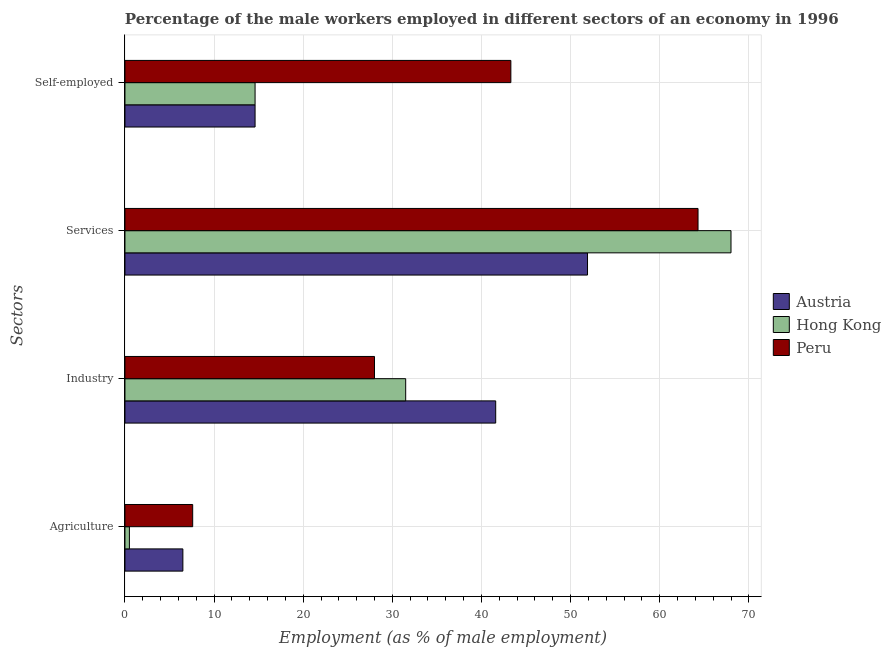How many different coloured bars are there?
Offer a very short reply. 3. How many groups of bars are there?
Ensure brevity in your answer.  4. Are the number of bars per tick equal to the number of legend labels?
Offer a terse response. Yes. Are the number of bars on each tick of the Y-axis equal?
Your answer should be compact. Yes. What is the label of the 3rd group of bars from the top?
Your answer should be compact. Industry. What is the percentage of male workers in services in Austria?
Provide a short and direct response. 51.9. Across all countries, what is the maximum percentage of male workers in agriculture?
Provide a short and direct response. 7.6. Across all countries, what is the minimum percentage of male workers in industry?
Make the answer very short. 28. In which country was the percentage of self employed male workers maximum?
Keep it short and to the point. Peru. What is the total percentage of self employed male workers in the graph?
Your answer should be very brief. 72.5. What is the difference between the percentage of self employed male workers in Austria and the percentage of male workers in services in Hong Kong?
Offer a terse response. -53.4. What is the average percentage of self employed male workers per country?
Offer a terse response. 24.17. What is the difference between the percentage of self employed male workers and percentage of male workers in services in Hong Kong?
Provide a short and direct response. -53.4. In how many countries, is the percentage of self employed male workers greater than 56 %?
Your response must be concise. 0. What is the ratio of the percentage of male workers in industry in Peru to that in Hong Kong?
Ensure brevity in your answer.  0.89. What is the difference between the highest and the second highest percentage of male workers in services?
Ensure brevity in your answer.  3.7. What is the difference between the highest and the lowest percentage of male workers in agriculture?
Offer a very short reply. 7.1. Is the sum of the percentage of male workers in industry in Peru and Austria greater than the maximum percentage of male workers in services across all countries?
Offer a very short reply. Yes. What does the 2nd bar from the bottom in Self-employed represents?
Your answer should be compact. Hong Kong. How many countries are there in the graph?
Provide a short and direct response. 3. What is the difference between two consecutive major ticks on the X-axis?
Offer a terse response. 10. Does the graph contain any zero values?
Provide a short and direct response. No. Where does the legend appear in the graph?
Make the answer very short. Center right. How many legend labels are there?
Provide a succinct answer. 3. What is the title of the graph?
Your response must be concise. Percentage of the male workers employed in different sectors of an economy in 1996. Does "Israel" appear as one of the legend labels in the graph?
Make the answer very short. No. What is the label or title of the X-axis?
Keep it short and to the point. Employment (as % of male employment). What is the label or title of the Y-axis?
Your response must be concise. Sectors. What is the Employment (as % of male employment) in Peru in Agriculture?
Your response must be concise. 7.6. What is the Employment (as % of male employment) in Austria in Industry?
Keep it short and to the point. 41.6. What is the Employment (as % of male employment) of Hong Kong in Industry?
Offer a terse response. 31.5. What is the Employment (as % of male employment) of Peru in Industry?
Your answer should be compact. 28. What is the Employment (as % of male employment) of Austria in Services?
Give a very brief answer. 51.9. What is the Employment (as % of male employment) of Hong Kong in Services?
Your response must be concise. 68. What is the Employment (as % of male employment) of Peru in Services?
Ensure brevity in your answer.  64.3. What is the Employment (as % of male employment) in Austria in Self-employed?
Offer a terse response. 14.6. What is the Employment (as % of male employment) in Hong Kong in Self-employed?
Your response must be concise. 14.6. What is the Employment (as % of male employment) of Peru in Self-employed?
Your answer should be compact. 43.3. Across all Sectors, what is the maximum Employment (as % of male employment) in Austria?
Your answer should be very brief. 51.9. Across all Sectors, what is the maximum Employment (as % of male employment) in Hong Kong?
Your answer should be compact. 68. Across all Sectors, what is the maximum Employment (as % of male employment) in Peru?
Make the answer very short. 64.3. Across all Sectors, what is the minimum Employment (as % of male employment) in Peru?
Provide a succinct answer. 7.6. What is the total Employment (as % of male employment) in Austria in the graph?
Ensure brevity in your answer.  114.6. What is the total Employment (as % of male employment) in Hong Kong in the graph?
Provide a succinct answer. 114.6. What is the total Employment (as % of male employment) in Peru in the graph?
Keep it short and to the point. 143.2. What is the difference between the Employment (as % of male employment) in Austria in Agriculture and that in Industry?
Ensure brevity in your answer.  -35.1. What is the difference between the Employment (as % of male employment) of Hong Kong in Agriculture and that in Industry?
Make the answer very short. -31. What is the difference between the Employment (as % of male employment) of Peru in Agriculture and that in Industry?
Give a very brief answer. -20.4. What is the difference between the Employment (as % of male employment) in Austria in Agriculture and that in Services?
Offer a very short reply. -45.4. What is the difference between the Employment (as % of male employment) in Hong Kong in Agriculture and that in Services?
Keep it short and to the point. -67.5. What is the difference between the Employment (as % of male employment) of Peru in Agriculture and that in Services?
Make the answer very short. -56.7. What is the difference between the Employment (as % of male employment) in Austria in Agriculture and that in Self-employed?
Offer a very short reply. -8.1. What is the difference between the Employment (as % of male employment) in Hong Kong in Agriculture and that in Self-employed?
Provide a short and direct response. -14.1. What is the difference between the Employment (as % of male employment) of Peru in Agriculture and that in Self-employed?
Offer a very short reply. -35.7. What is the difference between the Employment (as % of male employment) of Hong Kong in Industry and that in Services?
Ensure brevity in your answer.  -36.5. What is the difference between the Employment (as % of male employment) in Peru in Industry and that in Services?
Keep it short and to the point. -36.3. What is the difference between the Employment (as % of male employment) in Peru in Industry and that in Self-employed?
Your answer should be very brief. -15.3. What is the difference between the Employment (as % of male employment) of Austria in Services and that in Self-employed?
Provide a succinct answer. 37.3. What is the difference between the Employment (as % of male employment) in Hong Kong in Services and that in Self-employed?
Provide a succinct answer. 53.4. What is the difference between the Employment (as % of male employment) of Austria in Agriculture and the Employment (as % of male employment) of Peru in Industry?
Make the answer very short. -21.5. What is the difference between the Employment (as % of male employment) in Hong Kong in Agriculture and the Employment (as % of male employment) in Peru in Industry?
Provide a short and direct response. -27.5. What is the difference between the Employment (as % of male employment) in Austria in Agriculture and the Employment (as % of male employment) in Hong Kong in Services?
Offer a terse response. -61.5. What is the difference between the Employment (as % of male employment) in Austria in Agriculture and the Employment (as % of male employment) in Peru in Services?
Keep it short and to the point. -57.8. What is the difference between the Employment (as % of male employment) of Hong Kong in Agriculture and the Employment (as % of male employment) of Peru in Services?
Ensure brevity in your answer.  -63.8. What is the difference between the Employment (as % of male employment) of Austria in Agriculture and the Employment (as % of male employment) of Peru in Self-employed?
Your response must be concise. -36.8. What is the difference between the Employment (as % of male employment) in Hong Kong in Agriculture and the Employment (as % of male employment) in Peru in Self-employed?
Make the answer very short. -42.8. What is the difference between the Employment (as % of male employment) in Austria in Industry and the Employment (as % of male employment) in Hong Kong in Services?
Your answer should be very brief. -26.4. What is the difference between the Employment (as % of male employment) of Austria in Industry and the Employment (as % of male employment) of Peru in Services?
Offer a terse response. -22.7. What is the difference between the Employment (as % of male employment) of Hong Kong in Industry and the Employment (as % of male employment) of Peru in Services?
Your answer should be compact. -32.8. What is the difference between the Employment (as % of male employment) in Austria in Industry and the Employment (as % of male employment) in Hong Kong in Self-employed?
Your answer should be compact. 27. What is the difference between the Employment (as % of male employment) of Austria in Industry and the Employment (as % of male employment) of Peru in Self-employed?
Offer a very short reply. -1.7. What is the difference between the Employment (as % of male employment) of Hong Kong in Industry and the Employment (as % of male employment) of Peru in Self-employed?
Offer a terse response. -11.8. What is the difference between the Employment (as % of male employment) in Austria in Services and the Employment (as % of male employment) in Hong Kong in Self-employed?
Your response must be concise. 37.3. What is the difference between the Employment (as % of male employment) in Austria in Services and the Employment (as % of male employment) in Peru in Self-employed?
Make the answer very short. 8.6. What is the difference between the Employment (as % of male employment) in Hong Kong in Services and the Employment (as % of male employment) in Peru in Self-employed?
Offer a terse response. 24.7. What is the average Employment (as % of male employment) in Austria per Sectors?
Your response must be concise. 28.65. What is the average Employment (as % of male employment) of Hong Kong per Sectors?
Give a very brief answer. 28.65. What is the average Employment (as % of male employment) of Peru per Sectors?
Your answer should be very brief. 35.8. What is the difference between the Employment (as % of male employment) of Hong Kong and Employment (as % of male employment) of Peru in Agriculture?
Your response must be concise. -7.1. What is the difference between the Employment (as % of male employment) in Austria and Employment (as % of male employment) in Hong Kong in Industry?
Provide a succinct answer. 10.1. What is the difference between the Employment (as % of male employment) of Hong Kong and Employment (as % of male employment) of Peru in Industry?
Offer a very short reply. 3.5. What is the difference between the Employment (as % of male employment) of Austria and Employment (as % of male employment) of Hong Kong in Services?
Offer a terse response. -16.1. What is the difference between the Employment (as % of male employment) in Austria and Employment (as % of male employment) in Peru in Self-employed?
Your answer should be compact. -28.7. What is the difference between the Employment (as % of male employment) of Hong Kong and Employment (as % of male employment) of Peru in Self-employed?
Offer a terse response. -28.7. What is the ratio of the Employment (as % of male employment) of Austria in Agriculture to that in Industry?
Provide a short and direct response. 0.16. What is the ratio of the Employment (as % of male employment) in Hong Kong in Agriculture to that in Industry?
Make the answer very short. 0.02. What is the ratio of the Employment (as % of male employment) of Peru in Agriculture to that in Industry?
Provide a succinct answer. 0.27. What is the ratio of the Employment (as % of male employment) of Austria in Agriculture to that in Services?
Your response must be concise. 0.13. What is the ratio of the Employment (as % of male employment) in Hong Kong in Agriculture to that in Services?
Keep it short and to the point. 0.01. What is the ratio of the Employment (as % of male employment) in Peru in Agriculture to that in Services?
Your answer should be compact. 0.12. What is the ratio of the Employment (as % of male employment) of Austria in Agriculture to that in Self-employed?
Offer a terse response. 0.45. What is the ratio of the Employment (as % of male employment) in Hong Kong in Agriculture to that in Self-employed?
Your answer should be very brief. 0.03. What is the ratio of the Employment (as % of male employment) in Peru in Agriculture to that in Self-employed?
Your answer should be very brief. 0.18. What is the ratio of the Employment (as % of male employment) of Austria in Industry to that in Services?
Ensure brevity in your answer.  0.8. What is the ratio of the Employment (as % of male employment) in Hong Kong in Industry to that in Services?
Offer a very short reply. 0.46. What is the ratio of the Employment (as % of male employment) in Peru in Industry to that in Services?
Your answer should be compact. 0.44. What is the ratio of the Employment (as % of male employment) in Austria in Industry to that in Self-employed?
Offer a terse response. 2.85. What is the ratio of the Employment (as % of male employment) of Hong Kong in Industry to that in Self-employed?
Provide a succinct answer. 2.16. What is the ratio of the Employment (as % of male employment) in Peru in Industry to that in Self-employed?
Make the answer very short. 0.65. What is the ratio of the Employment (as % of male employment) in Austria in Services to that in Self-employed?
Your answer should be very brief. 3.55. What is the ratio of the Employment (as % of male employment) in Hong Kong in Services to that in Self-employed?
Make the answer very short. 4.66. What is the ratio of the Employment (as % of male employment) of Peru in Services to that in Self-employed?
Your response must be concise. 1.49. What is the difference between the highest and the second highest Employment (as % of male employment) of Austria?
Keep it short and to the point. 10.3. What is the difference between the highest and the second highest Employment (as % of male employment) of Hong Kong?
Offer a very short reply. 36.5. What is the difference between the highest and the lowest Employment (as % of male employment) in Austria?
Offer a terse response. 45.4. What is the difference between the highest and the lowest Employment (as % of male employment) of Hong Kong?
Keep it short and to the point. 67.5. What is the difference between the highest and the lowest Employment (as % of male employment) in Peru?
Keep it short and to the point. 56.7. 